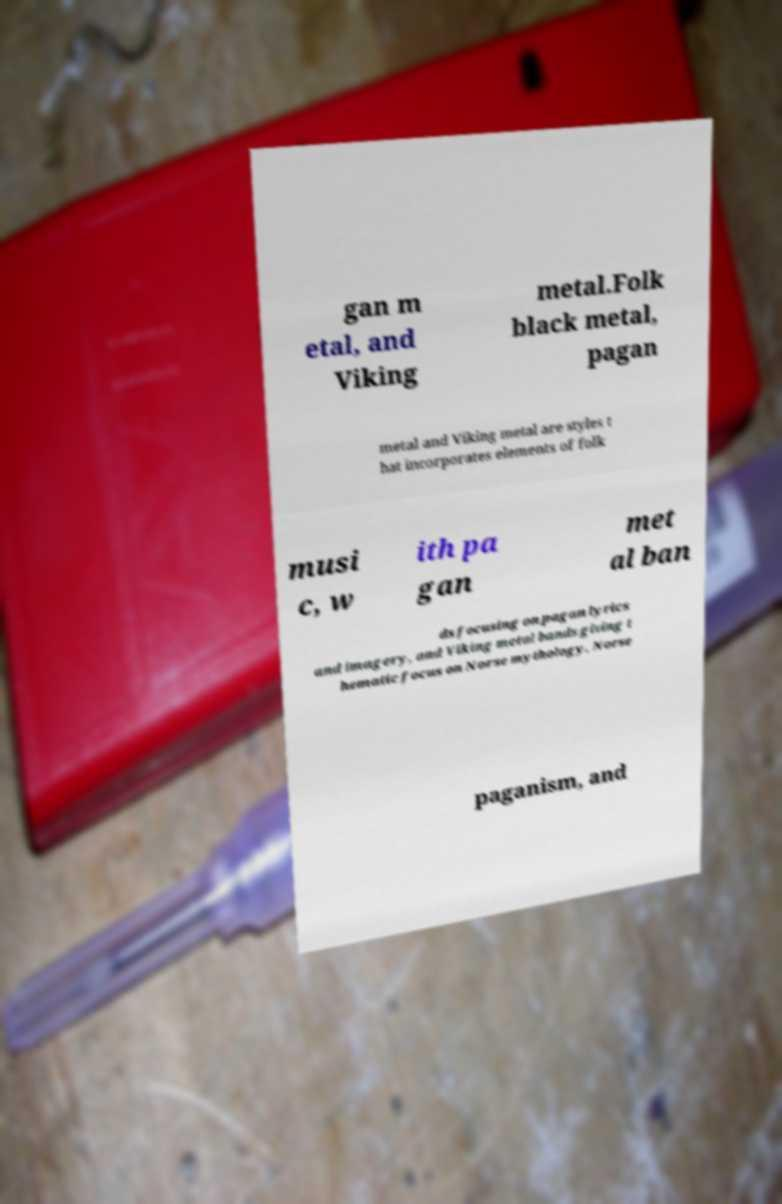There's text embedded in this image that I need extracted. Can you transcribe it verbatim? gan m etal, and Viking metal.Folk black metal, pagan metal and Viking metal are styles t hat incorporates elements of folk musi c, w ith pa gan met al ban ds focusing on pagan lyrics and imagery, and Viking metal bands giving t hematic focus on Norse mythology, Norse paganism, and 